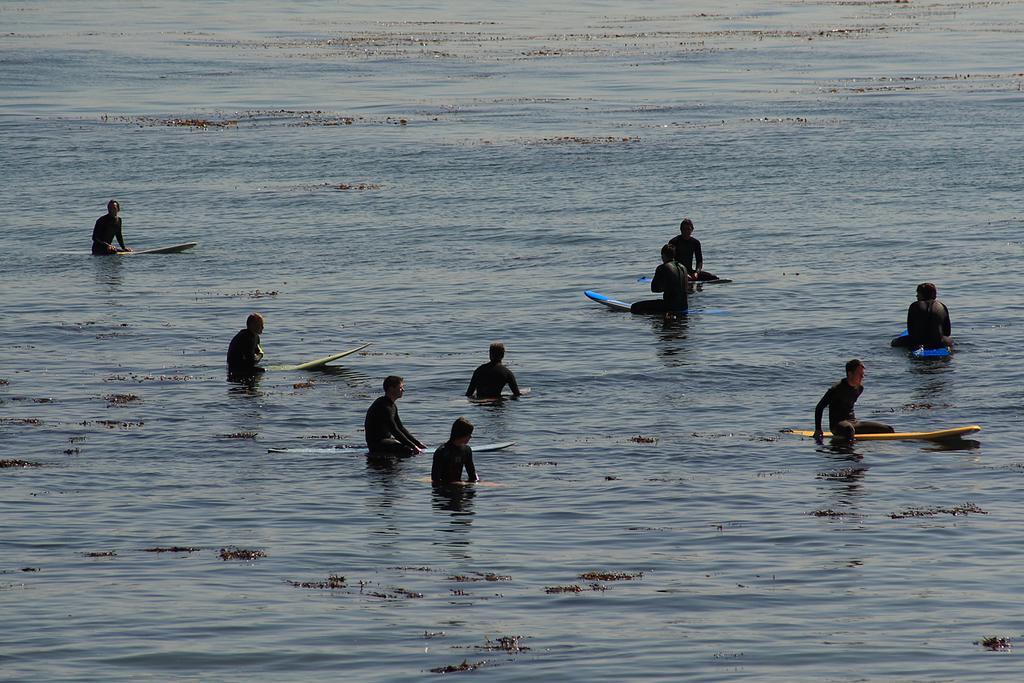Please provide a concise description of this image. In the picture I can see these people are floating on the water using surfboards. 